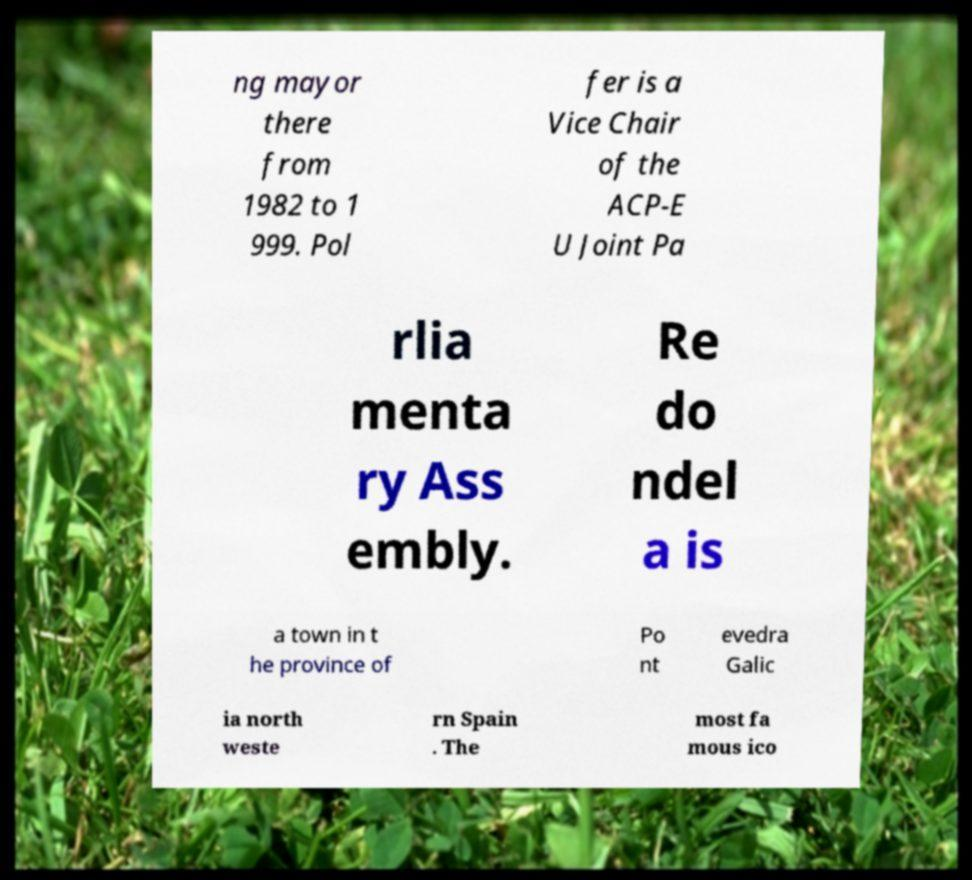I need the written content from this picture converted into text. Can you do that? ng mayor there from 1982 to 1 999. Pol fer is a Vice Chair of the ACP-E U Joint Pa rlia menta ry Ass embly. Re do ndel a is a town in t he province of Po nt evedra Galic ia north weste rn Spain . The most fa mous ico 